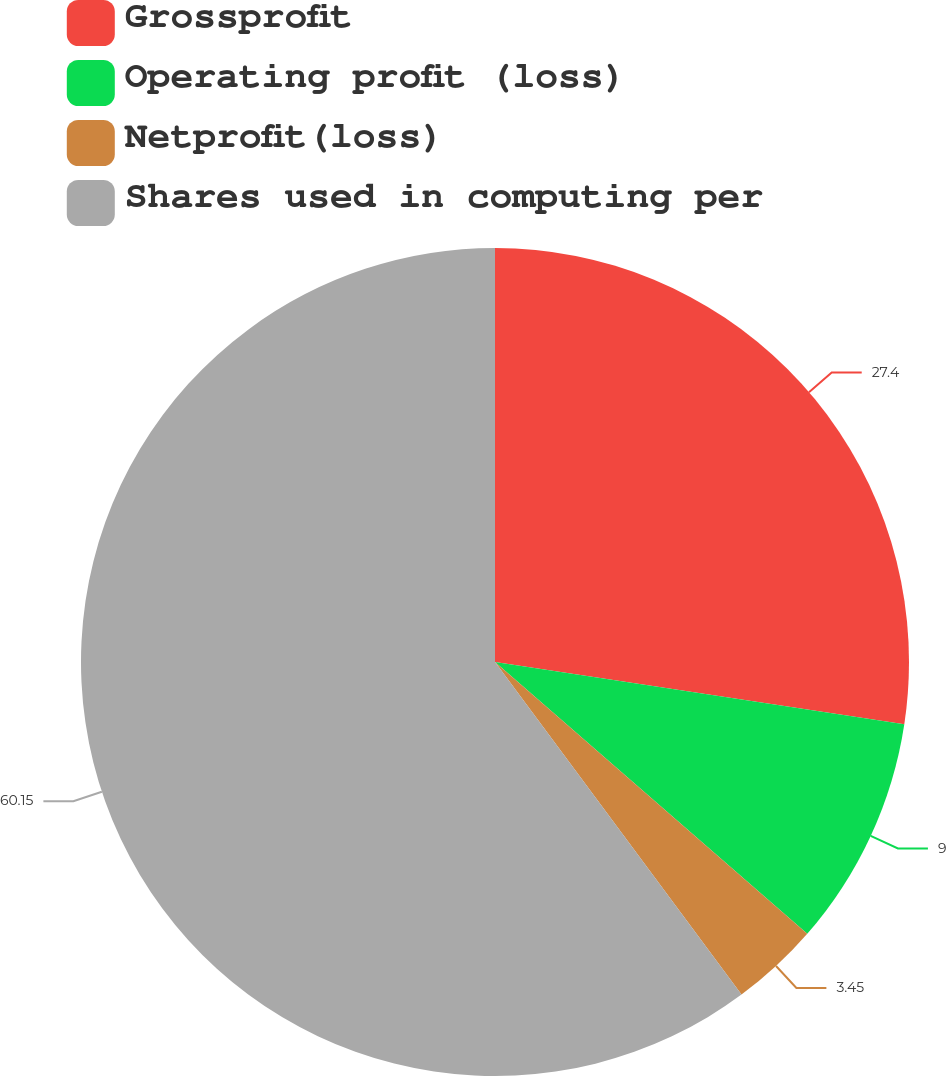Convert chart to OTSL. <chart><loc_0><loc_0><loc_500><loc_500><pie_chart><fcel>Grossprofit<fcel>Operating profit (loss)<fcel>Netprofit(loss)<fcel>Shares used in computing per<nl><fcel>27.4%<fcel>9.0%<fcel>3.45%<fcel>60.15%<nl></chart> 